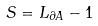<formula> <loc_0><loc_0><loc_500><loc_500>S = L _ { \partial A } - 1</formula> 